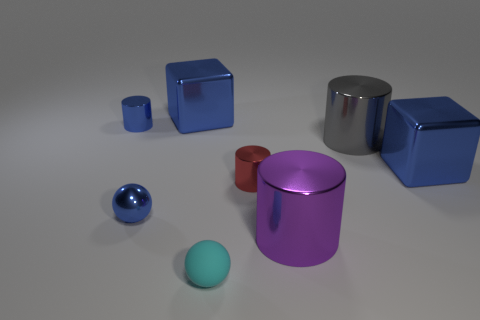Subtract all blue cubes. How many were subtracted if there are1blue cubes left? 1 Subtract all yellow cylinders. Subtract all red cubes. How many cylinders are left? 4 Add 2 purple metal spheres. How many objects exist? 10 Subtract 0 gray cubes. How many objects are left? 8 Subtract all small blue shiny balls. Subtract all rubber spheres. How many objects are left? 6 Add 8 metallic blocks. How many metallic blocks are left? 10 Add 2 small cylinders. How many small cylinders exist? 4 